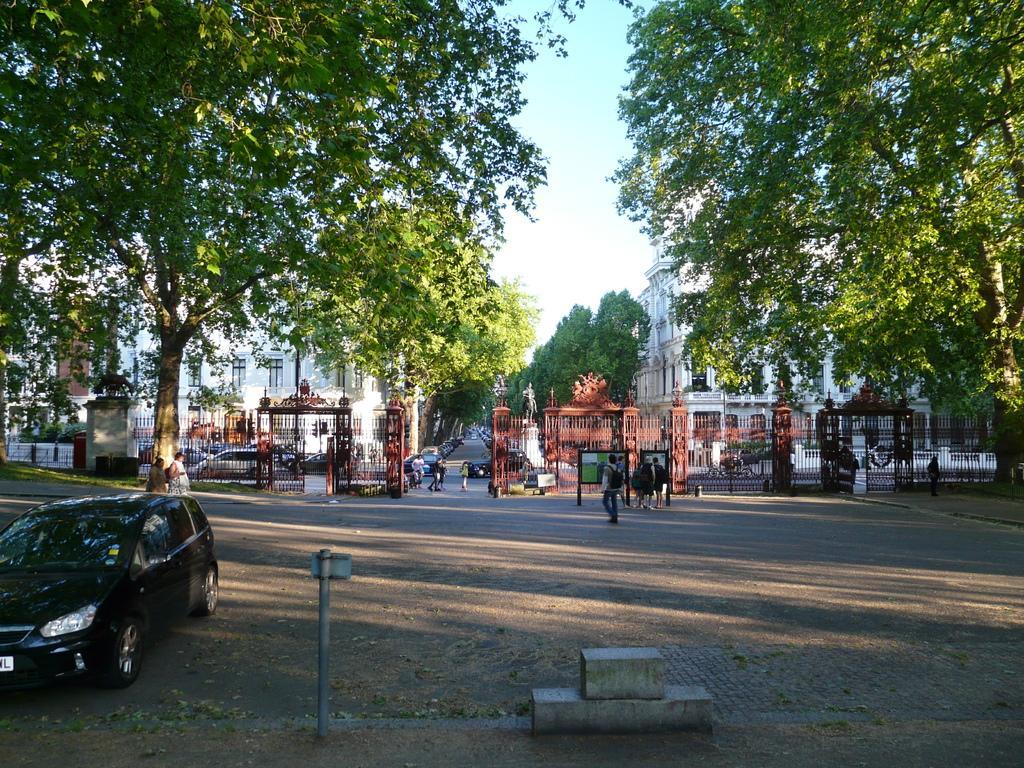Could you give a brief overview of what you see in this image? As we can see in the image there are few people, vehicles, trees, buildings and at the top there is sky. 